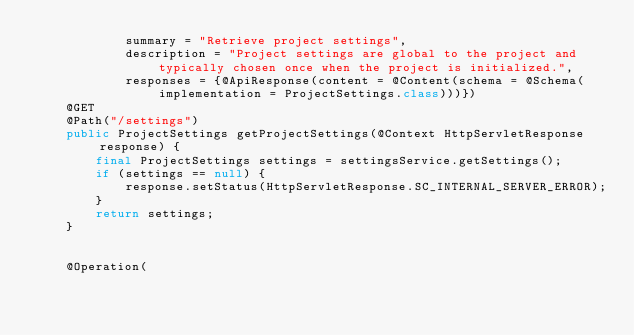Convert code to text. <code><loc_0><loc_0><loc_500><loc_500><_Java_>            summary = "Retrieve project settings",
            description = "Project settings are global to the project and typically chosen once when the project is initialized.",
            responses = {@ApiResponse(content = @Content(schema = @Schema(implementation = ProjectSettings.class)))})
    @GET
    @Path("/settings")
    public ProjectSettings getProjectSettings(@Context HttpServletResponse response) {
        final ProjectSettings settings = settingsService.getSettings();
        if (settings == null) {
            response.setStatus(HttpServletResponse.SC_INTERNAL_SERVER_ERROR);
        }
        return settings;
    }


    @Operation(</code> 